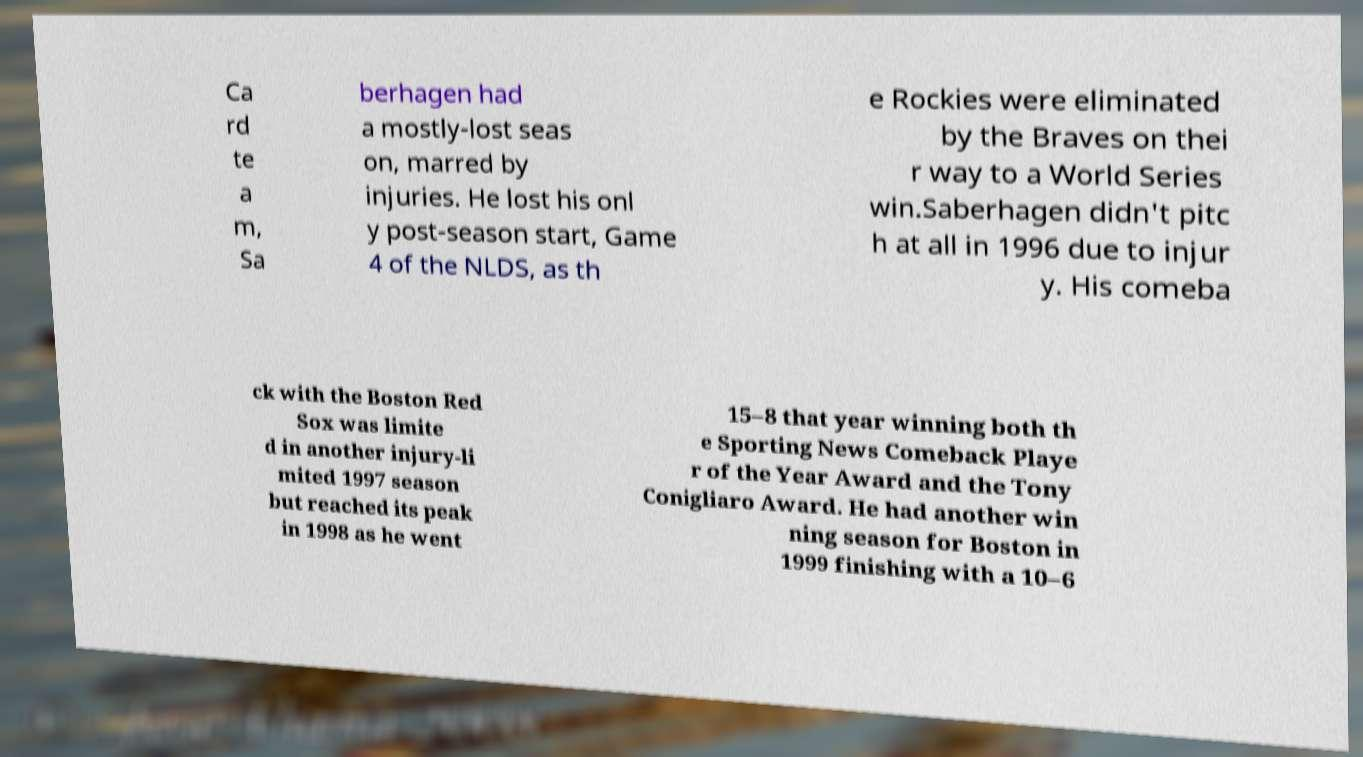What messages or text are displayed in this image? I need them in a readable, typed format. Ca rd te a m, Sa berhagen had a mostly-lost seas on, marred by injuries. He lost his onl y post-season start, Game 4 of the NLDS, as th e Rockies were eliminated by the Braves on thei r way to a World Series win.Saberhagen didn't pitc h at all in 1996 due to injur y. His comeba ck with the Boston Red Sox was limite d in another injury-li mited 1997 season but reached its peak in 1998 as he went 15–8 that year winning both th e Sporting News Comeback Playe r of the Year Award and the Tony Conigliaro Award. He had another win ning season for Boston in 1999 finishing with a 10–6 